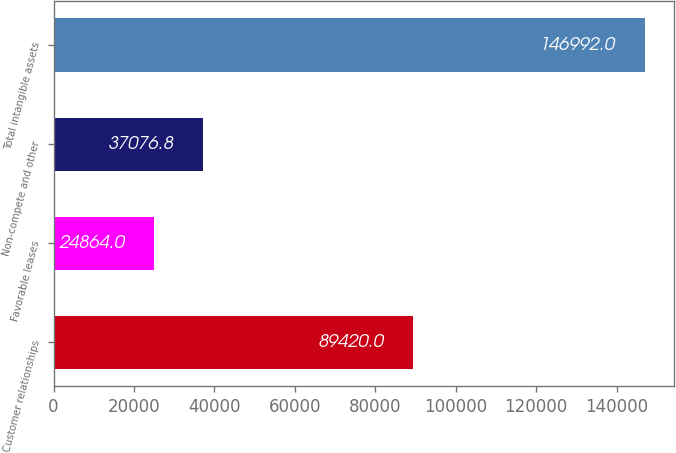Convert chart. <chart><loc_0><loc_0><loc_500><loc_500><bar_chart><fcel>Customer relationships<fcel>Favorable leases<fcel>Non-compete and other<fcel>Total intangible assets<nl><fcel>89420<fcel>24864<fcel>37076.8<fcel>146992<nl></chart> 